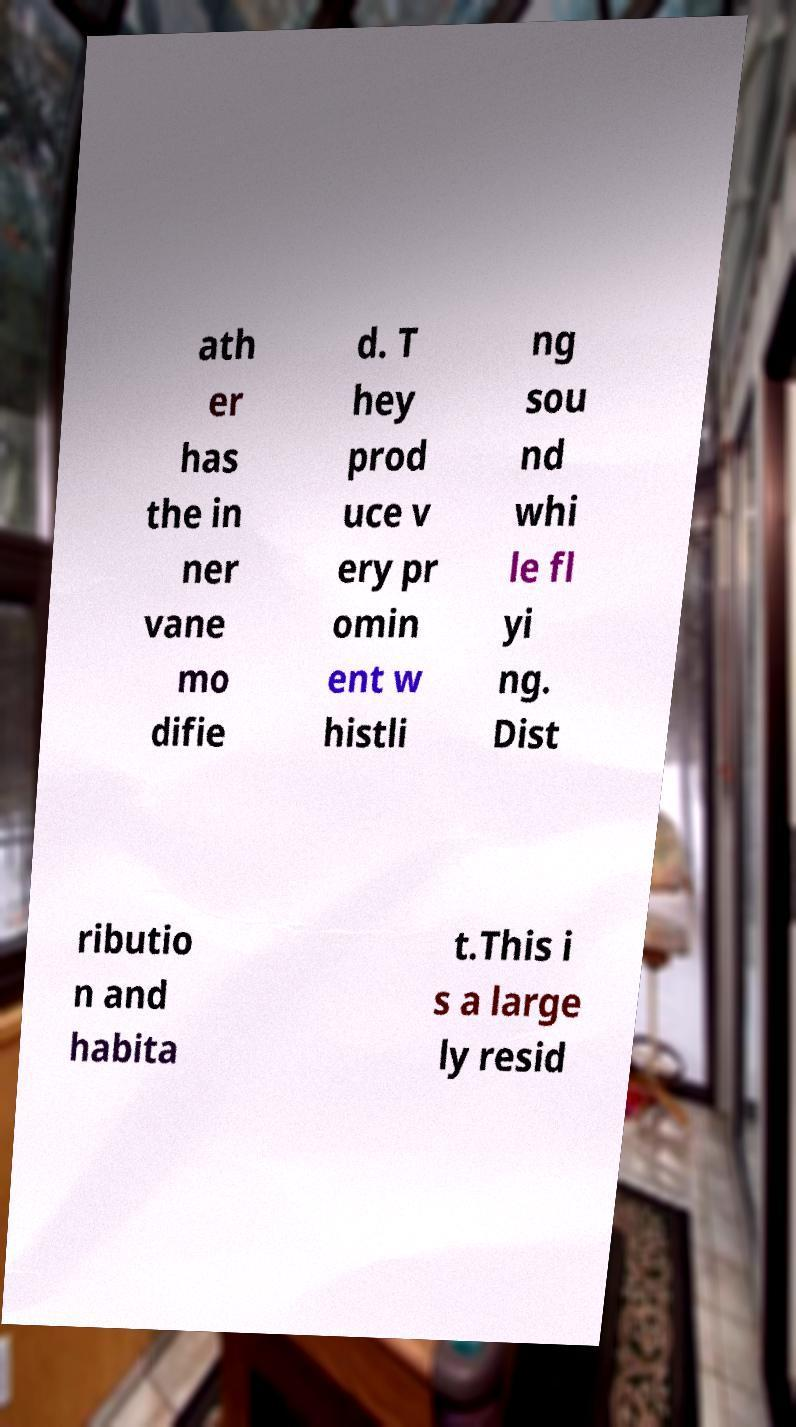Please identify and transcribe the text found in this image. ath er has the in ner vane mo difie d. T hey prod uce v ery pr omin ent w histli ng sou nd whi le fl yi ng. Dist ributio n and habita t.This i s a large ly resid 